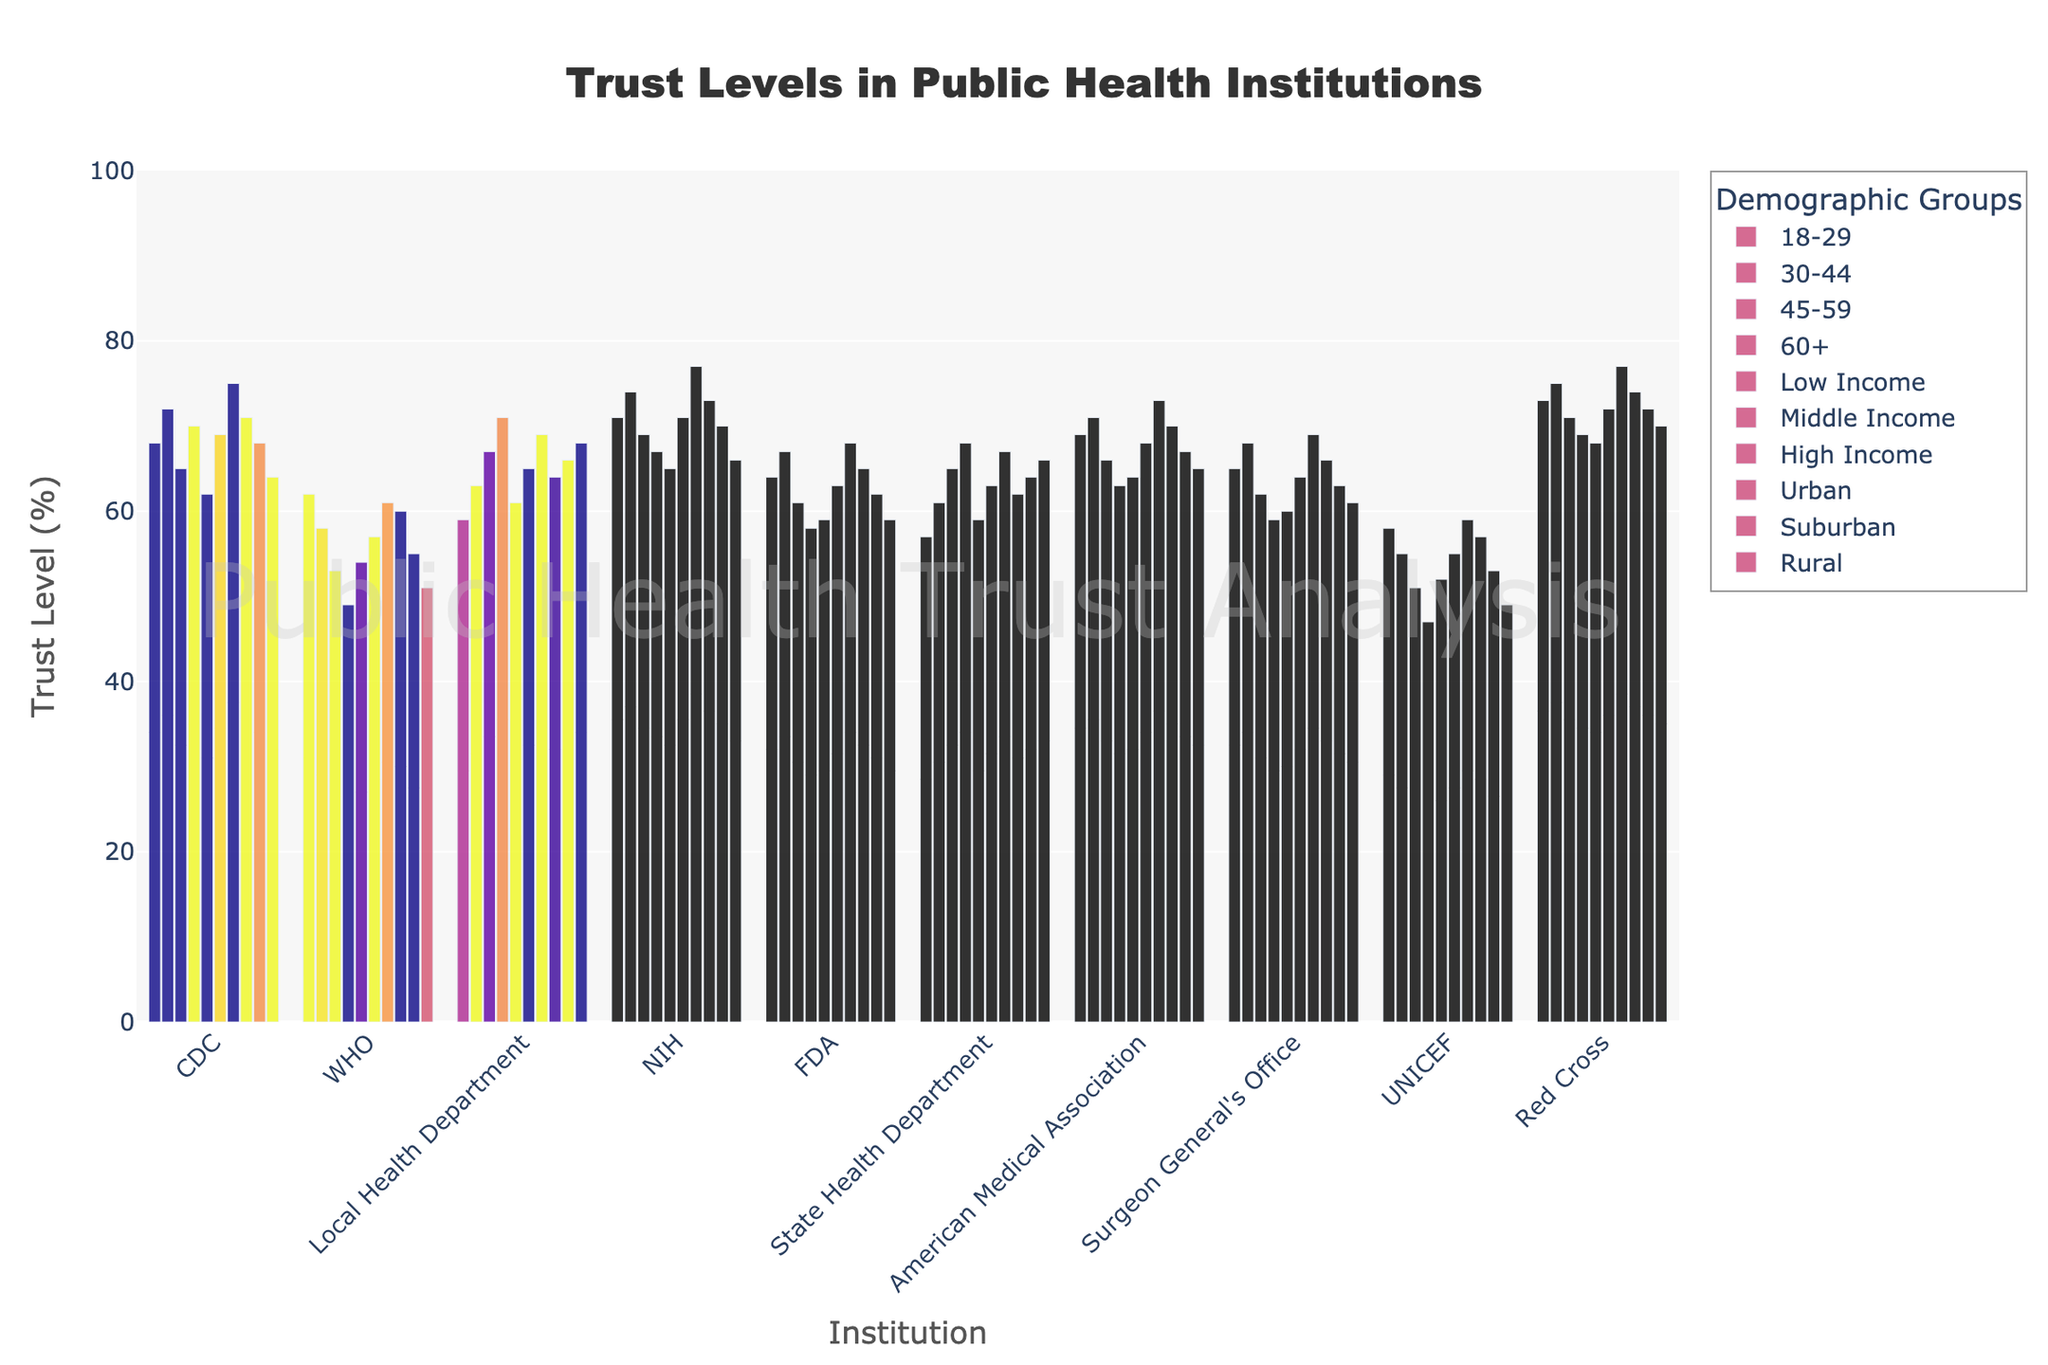Which institution has the highest trust level among the 45-59 age group? Look at the bar heights corresponding to the "45-59" age group. The tallest bar indicates the highest trust level. For the 45-59 age group, NIH has the highest trust level at 69%.
Answer: NIH Which demographic group shows the highest trust level in the CDC? Look at the bars representing the CDC across all demographic groups. The bar with the greatest height indicates the highest trust level. The "High Income" group shows the highest trust level in the CDC at 75%.
Answer: High Income Compare the trust levels in the WHO and the Red Cross among the Urban population. Which institution is more trusted? Examine the bars representing the Urban population's trust levels in the WHO and the Red Cross. The Red Cross has a higher bar at 74%, whereas the WHO is at 60%. Thus, the Red Cross is more trusted.
Answer: Red Cross What is the average trust level in the FDA across all age groups? Find the trust levels of the FDA for the 18-29 (64), 30-44 (67), 45-59 (61), and 60+ (58) age groups. Sum them up (64 + 67 + 61 + 58) = 250, then divide by 4. This gives an average of 250/4 = 62.5%.
Answer: 62.5% What is the difference in trust levels for NIH between the Suburban and Rural populations? Look at the trust levels for NIH in the Suburban (70%) and Rural (66%) populations. The difference is 70 - 66 = 4%.
Answer: 4% Which institution has the lowest trust level in the 60+ age group? Locate the bars representing the 60+ age group's trust levels. The lowest bar determines the lowest trust level, which is for UNICEF at 47%.
Answer: UNICEF What is the sum of trust levels in Local Health Department for all income groups? Add the trust levels of Local Health Department for Low (61), Middle (65), and High (69) income groups. The sum is 61 + 65 + 69 = 195%.
Answer: 195% Among the various demographic groups, which group shows the most consistent (least variation) trust levels in public health institutions? Examine the bars for each demographic group. The group with the least variation in bar heights indicates the most consistent trust levels. By observation, High Income has narrower variations across its bars compared to others.
Answer: High Income How do the trust levels of the Surgeon General's Office compare between the Middle Income and High Income groups? Compare the bar heights for the Middle Income (64%) and High Income (69%) groups for the Surgeon General's Office. The trust level is higher in the High Income group by 5%.
Answer: 5% higher in High Income Which institution is most trusted by the Rural population? Look at the bars representing the Rural population and identify the tallest one. The Red Cross at 70% has the highest trust level among the Rural population.
Answer: Red Cross 